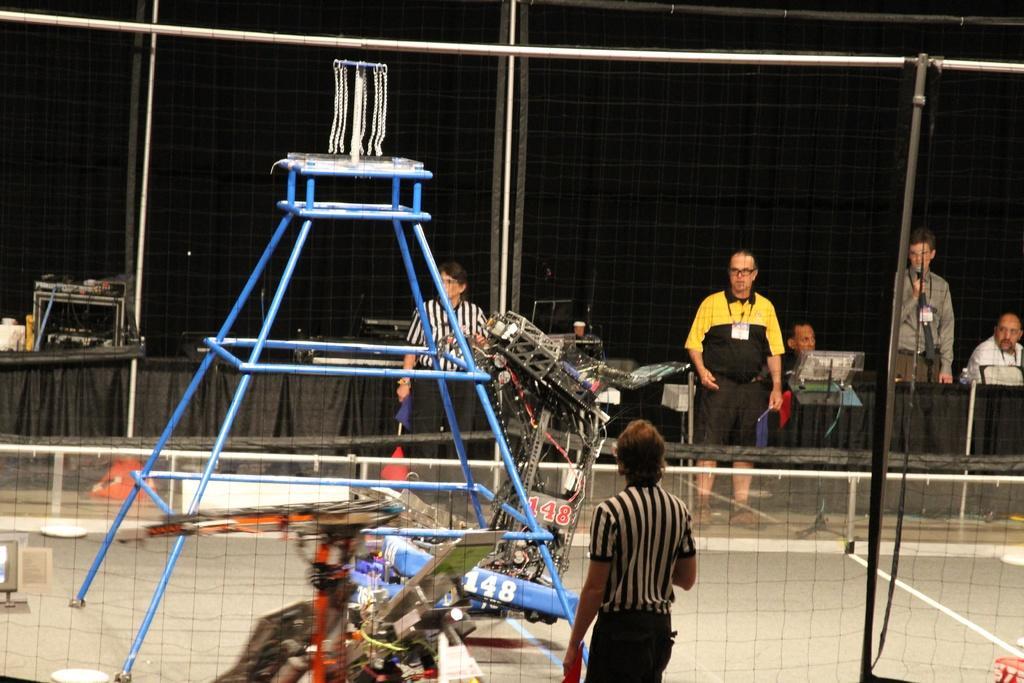In one or two sentences, can you explain what this image depicts? At the bottom of this image, there is a person and a net which is having holes. Through this net, we can see there are persons, a sheet, a court and other objects. And the background is dark in color. 